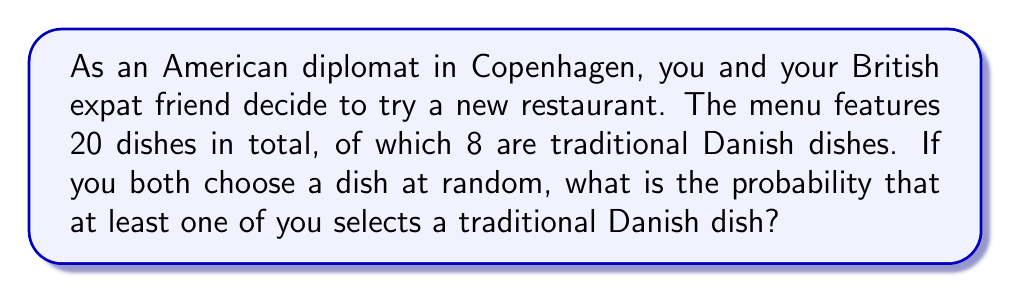Solve this math problem. Let's approach this step-by-step:

1) First, let's calculate the probability of selecting a traditional Danish dish:
   $P(\text{Danish}) = \frac{8}{20} = \frac{2}{5} = 0.4$

2) The probability of not selecting a Danish dish is:
   $P(\text{Not Danish}) = 1 - \frac{2}{5} = \frac{3}{5} = 0.6$

3) For at least one of you to select a Danish dish, we can calculate the probability of the complement event: neither of you selecting a Danish dish.

4) The probability of neither of you selecting a Danish dish is:
   $P(\text{Both Not Danish}) = \frac{3}{5} \times \frac{3}{5} = \frac{9}{25} = 0.36$

5) Therefore, the probability of at least one of you selecting a Danish dish is:
   $P(\text{At least one Danish}) = 1 - P(\text{Both Not Danish})$
   $= 1 - \frac{9}{25} = \frac{25}{25} - \frac{9}{25} = \frac{16}{25} = 0.64$

Thus, there is a 64% chance that at least one of you will select a traditional Danish dish.
Answer: $\frac{16}{25}$ or $0.64$ or $64\%$ 